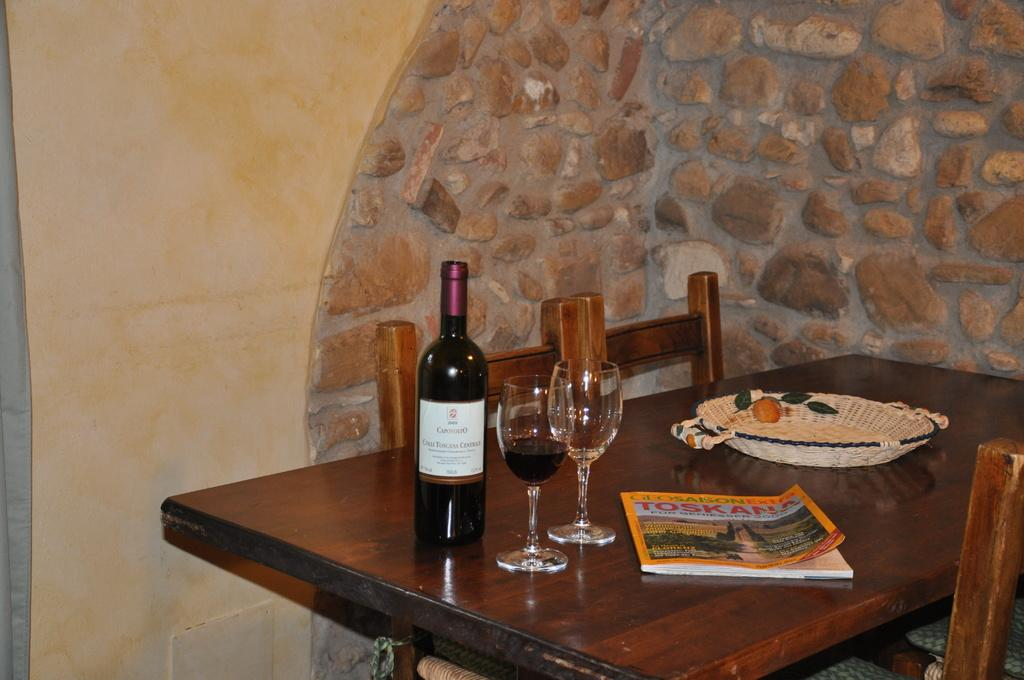What type of table is in the image? There is a wooden table in the image. What is on the wooden table? There is a wine bottle, two glasses, a basket, and a magazine on the table. How many chairs are in the image? There are chairs in the image. Can you describe the contents of the basket on the table? The facts provided do not specify the contents of the basket. What time does the clock on the table show in the image? There is no clock present in the image. How many bites have been taken out of the wine bottle in the image? The wine bottle is not a food item, so it cannot be bitten. 